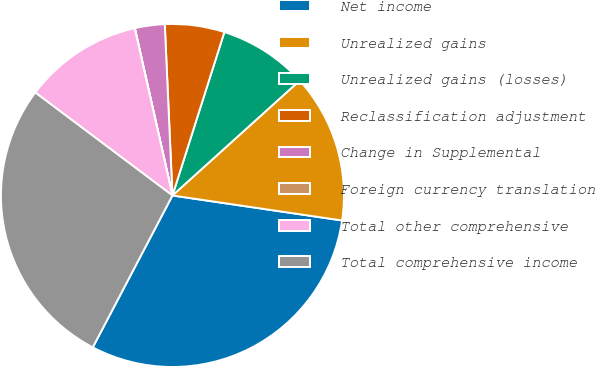Convert chart. <chart><loc_0><loc_0><loc_500><loc_500><pie_chart><fcel>Net income<fcel>Unrealized gains<fcel>Unrealized gains (losses)<fcel>Reclassification adjustment<fcel>Change in Supplemental<fcel>Foreign currency translation<fcel>Total other comprehensive<fcel>Total comprehensive income<nl><fcel>30.36%<fcel>14.02%<fcel>8.41%<fcel>5.61%<fcel>2.81%<fcel>0.01%<fcel>11.22%<fcel>27.56%<nl></chart> 